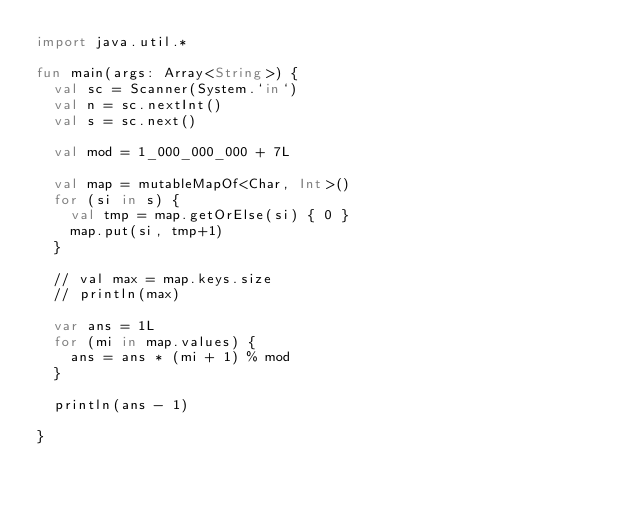Convert code to text. <code><loc_0><loc_0><loc_500><loc_500><_Kotlin_>import java.util.*

fun main(args: Array<String>) {
  val sc = Scanner(System.`in`)
  val n = sc.nextInt()
  val s = sc.next()

  val mod = 1_000_000_000 + 7L

  val map = mutableMapOf<Char, Int>()
  for (si in s) {
    val tmp = map.getOrElse(si) { 0 }
    map.put(si, tmp+1)
  }

  // val max = map.keys.size
  // println(max)

  var ans = 1L
  for (mi in map.values) {
    ans = ans * (mi + 1) % mod
  }

  println(ans - 1)

}
</code> 